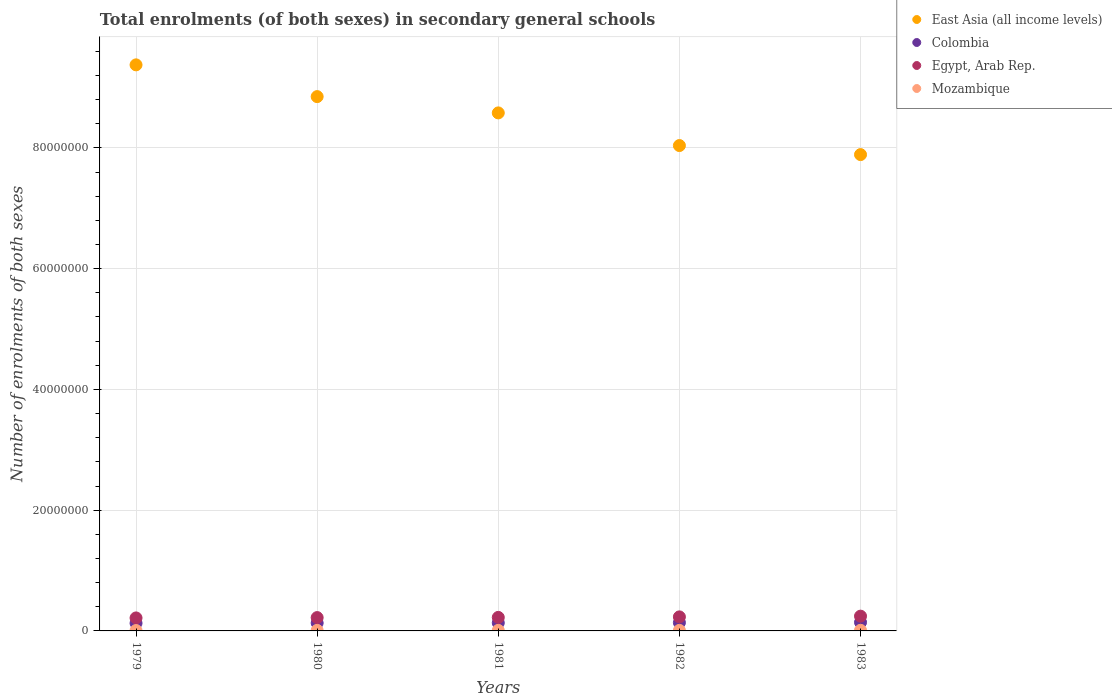How many different coloured dotlines are there?
Your answer should be compact. 4. Is the number of dotlines equal to the number of legend labels?
Provide a succinct answer. Yes. What is the number of enrolments in secondary schools in Colombia in 1982?
Make the answer very short. 1.37e+06. Across all years, what is the maximum number of enrolments in secondary schools in East Asia (all income levels)?
Your answer should be very brief. 9.38e+07. Across all years, what is the minimum number of enrolments in secondary schools in East Asia (all income levels)?
Ensure brevity in your answer.  7.89e+07. In which year was the number of enrolments in secondary schools in Colombia minimum?
Offer a very short reply. 1979. What is the total number of enrolments in secondary schools in Mozambique in the graph?
Give a very brief answer. 4.46e+05. What is the difference between the number of enrolments in secondary schools in East Asia (all income levels) in 1979 and that in 1981?
Provide a succinct answer. 7.96e+06. What is the difference between the number of enrolments in secondary schools in Mozambique in 1981 and the number of enrolments in secondary schools in Egypt, Arab Rep. in 1982?
Ensure brevity in your answer.  -2.24e+06. What is the average number of enrolments in secondary schools in Mozambique per year?
Offer a terse response. 8.91e+04. In the year 1983, what is the difference between the number of enrolments in secondary schools in Colombia and number of enrolments in secondary schools in East Asia (all income levels)?
Offer a terse response. -7.75e+07. In how many years, is the number of enrolments in secondary schools in Colombia greater than 20000000?
Provide a short and direct response. 0. What is the ratio of the number of enrolments in secondary schools in Egypt, Arab Rep. in 1979 to that in 1981?
Your answer should be compact. 0.96. Is the number of enrolments in secondary schools in East Asia (all income levels) in 1980 less than that in 1983?
Make the answer very short. No. Is the difference between the number of enrolments in secondary schools in Colombia in 1979 and 1980 greater than the difference between the number of enrolments in secondary schools in East Asia (all income levels) in 1979 and 1980?
Provide a short and direct response. No. What is the difference between the highest and the second highest number of enrolments in secondary schools in East Asia (all income levels)?
Offer a very short reply. 5.26e+06. What is the difference between the highest and the lowest number of enrolments in secondary schools in Egypt, Arab Rep.?
Keep it short and to the point. 2.93e+05. Is it the case that in every year, the sum of the number of enrolments in secondary schools in East Asia (all income levels) and number of enrolments in secondary schools in Mozambique  is greater than the sum of number of enrolments in secondary schools in Colombia and number of enrolments in secondary schools in Egypt, Arab Rep.?
Provide a succinct answer. No. Is the number of enrolments in secondary schools in Mozambique strictly greater than the number of enrolments in secondary schools in Egypt, Arab Rep. over the years?
Your answer should be compact. No. What is the title of the graph?
Your answer should be very brief. Total enrolments (of both sexes) in secondary general schools. What is the label or title of the Y-axis?
Your answer should be very brief. Number of enrolments of both sexes. What is the Number of enrolments of both sexes of East Asia (all income levels) in 1979?
Give a very brief answer. 9.38e+07. What is the Number of enrolments of both sexes in Colombia in 1979?
Your response must be concise. 1.28e+06. What is the Number of enrolments of both sexes of Egypt, Arab Rep. in 1979?
Provide a succinct answer. 2.15e+06. What is the Number of enrolments of both sexes of Mozambique in 1979?
Offer a very short reply. 6.74e+04. What is the Number of enrolments of both sexes in East Asia (all income levels) in 1980?
Ensure brevity in your answer.  8.85e+07. What is the Number of enrolments of both sexes in Colombia in 1980?
Your response must be concise. 1.31e+06. What is the Number of enrolments of both sexes in Egypt, Arab Rep. in 1980?
Provide a succinct answer. 2.21e+06. What is the Number of enrolments of both sexes in Mozambique in 1980?
Your response must be concise. 9.28e+04. What is the Number of enrolments of both sexes of East Asia (all income levels) in 1981?
Provide a succinct answer. 8.58e+07. What is the Number of enrolments of both sexes in Colombia in 1981?
Your answer should be very brief. 1.34e+06. What is the Number of enrolments of both sexes in Egypt, Arab Rep. in 1981?
Keep it short and to the point. 2.24e+06. What is the Number of enrolments of both sexes of Mozambique in 1981?
Make the answer very short. 9.00e+04. What is the Number of enrolments of both sexes in East Asia (all income levels) in 1982?
Ensure brevity in your answer.  8.04e+07. What is the Number of enrolments of both sexes of Colombia in 1982?
Ensure brevity in your answer.  1.37e+06. What is the Number of enrolments of both sexes in Egypt, Arab Rep. in 1982?
Ensure brevity in your answer.  2.33e+06. What is the Number of enrolments of both sexes of Mozambique in 1982?
Provide a short and direct response. 8.98e+04. What is the Number of enrolments of both sexes of East Asia (all income levels) in 1983?
Your response must be concise. 7.89e+07. What is the Number of enrolments of both sexes of Colombia in 1983?
Provide a short and direct response. 1.42e+06. What is the Number of enrolments of both sexes of Egypt, Arab Rep. in 1983?
Give a very brief answer. 2.45e+06. What is the Number of enrolments of both sexes in Mozambique in 1983?
Keep it short and to the point. 1.05e+05. Across all years, what is the maximum Number of enrolments of both sexes of East Asia (all income levels)?
Give a very brief answer. 9.38e+07. Across all years, what is the maximum Number of enrolments of both sexes in Colombia?
Make the answer very short. 1.42e+06. Across all years, what is the maximum Number of enrolments of both sexes of Egypt, Arab Rep.?
Keep it short and to the point. 2.45e+06. Across all years, what is the maximum Number of enrolments of both sexes in Mozambique?
Offer a very short reply. 1.05e+05. Across all years, what is the minimum Number of enrolments of both sexes in East Asia (all income levels)?
Give a very brief answer. 7.89e+07. Across all years, what is the minimum Number of enrolments of both sexes in Colombia?
Ensure brevity in your answer.  1.28e+06. Across all years, what is the minimum Number of enrolments of both sexes in Egypt, Arab Rep.?
Offer a terse response. 2.15e+06. Across all years, what is the minimum Number of enrolments of both sexes in Mozambique?
Your answer should be compact. 6.74e+04. What is the total Number of enrolments of both sexes of East Asia (all income levels) in the graph?
Keep it short and to the point. 4.27e+08. What is the total Number of enrolments of both sexes in Colombia in the graph?
Your answer should be compact. 6.73e+06. What is the total Number of enrolments of both sexes in Egypt, Arab Rep. in the graph?
Ensure brevity in your answer.  1.14e+07. What is the total Number of enrolments of both sexes of Mozambique in the graph?
Offer a very short reply. 4.46e+05. What is the difference between the Number of enrolments of both sexes of East Asia (all income levels) in 1979 and that in 1980?
Give a very brief answer. 5.26e+06. What is the difference between the Number of enrolments of both sexes of Colombia in 1979 and that in 1980?
Your answer should be very brief. -3.55e+04. What is the difference between the Number of enrolments of both sexes in Egypt, Arab Rep. in 1979 and that in 1980?
Your response must be concise. -5.67e+04. What is the difference between the Number of enrolments of both sexes of Mozambique in 1979 and that in 1980?
Your response must be concise. -2.54e+04. What is the difference between the Number of enrolments of both sexes in East Asia (all income levels) in 1979 and that in 1981?
Give a very brief answer. 7.96e+06. What is the difference between the Number of enrolments of both sexes in Colombia in 1979 and that in 1981?
Make the answer very short. -6.07e+04. What is the difference between the Number of enrolments of both sexes in Egypt, Arab Rep. in 1979 and that in 1981?
Ensure brevity in your answer.  -8.68e+04. What is the difference between the Number of enrolments of both sexes of Mozambique in 1979 and that in 1981?
Make the answer very short. -2.26e+04. What is the difference between the Number of enrolments of both sexes in East Asia (all income levels) in 1979 and that in 1982?
Your response must be concise. 1.34e+07. What is the difference between the Number of enrolments of both sexes of Colombia in 1979 and that in 1982?
Ensure brevity in your answer.  -9.71e+04. What is the difference between the Number of enrolments of both sexes in Egypt, Arab Rep. in 1979 and that in 1982?
Provide a short and direct response. -1.74e+05. What is the difference between the Number of enrolments of both sexes in Mozambique in 1979 and that in 1982?
Make the answer very short. -2.24e+04. What is the difference between the Number of enrolments of both sexes of East Asia (all income levels) in 1979 and that in 1983?
Provide a short and direct response. 1.49e+07. What is the difference between the Number of enrolments of both sexes in Colombia in 1979 and that in 1983?
Ensure brevity in your answer.  -1.47e+05. What is the difference between the Number of enrolments of both sexes in Egypt, Arab Rep. in 1979 and that in 1983?
Keep it short and to the point. -2.93e+05. What is the difference between the Number of enrolments of both sexes of Mozambique in 1979 and that in 1983?
Provide a short and direct response. -3.80e+04. What is the difference between the Number of enrolments of both sexes in East Asia (all income levels) in 1980 and that in 1981?
Ensure brevity in your answer.  2.70e+06. What is the difference between the Number of enrolments of both sexes in Colombia in 1980 and that in 1981?
Make the answer very short. -2.52e+04. What is the difference between the Number of enrolments of both sexes of Egypt, Arab Rep. in 1980 and that in 1981?
Provide a succinct answer. -3.02e+04. What is the difference between the Number of enrolments of both sexes in Mozambique in 1980 and that in 1981?
Offer a terse response. 2774. What is the difference between the Number of enrolments of both sexes in East Asia (all income levels) in 1980 and that in 1982?
Offer a very short reply. 8.11e+06. What is the difference between the Number of enrolments of both sexes in Colombia in 1980 and that in 1982?
Your response must be concise. -6.17e+04. What is the difference between the Number of enrolments of both sexes of Egypt, Arab Rep. in 1980 and that in 1982?
Your answer should be compact. -1.18e+05. What is the difference between the Number of enrolments of both sexes in Mozambique in 1980 and that in 1982?
Provide a succinct answer. 2980. What is the difference between the Number of enrolments of both sexes of East Asia (all income levels) in 1980 and that in 1983?
Your answer should be very brief. 9.61e+06. What is the difference between the Number of enrolments of both sexes of Colombia in 1980 and that in 1983?
Make the answer very short. -1.11e+05. What is the difference between the Number of enrolments of both sexes of Egypt, Arab Rep. in 1980 and that in 1983?
Offer a terse response. -2.37e+05. What is the difference between the Number of enrolments of both sexes of Mozambique in 1980 and that in 1983?
Give a very brief answer. -1.26e+04. What is the difference between the Number of enrolments of both sexes in East Asia (all income levels) in 1981 and that in 1982?
Provide a short and direct response. 5.41e+06. What is the difference between the Number of enrolments of both sexes in Colombia in 1981 and that in 1982?
Give a very brief answer. -3.65e+04. What is the difference between the Number of enrolments of both sexes in Egypt, Arab Rep. in 1981 and that in 1982?
Ensure brevity in your answer.  -8.73e+04. What is the difference between the Number of enrolments of both sexes of Mozambique in 1981 and that in 1982?
Your response must be concise. 206. What is the difference between the Number of enrolments of both sexes in East Asia (all income levels) in 1981 and that in 1983?
Offer a very short reply. 6.91e+06. What is the difference between the Number of enrolments of both sexes in Colombia in 1981 and that in 1983?
Provide a succinct answer. -8.62e+04. What is the difference between the Number of enrolments of both sexes of Egypt, Arab Rep. in 1981 and that in 1983?
Keep it short and to the point. -2.07e+05. What is the difference between the Number of enrolments of both sexes in Mozambique in 1981 and that in 1983?
Your answer should be very brief. -1.54e+04. What is the difference between the Number of enrolments of both sexes of East Asia (all income levels) in 1982 and that in 1983?
Give a very brief answer. 1.50e+06. What is the difference between the Number of enrolments of both sexes in Colombia in 1982 and that in 1983?
Provide a short and direct response. -4.97e+04. What is the difference between the Number of enrolments of both sexes in Egypt, Arab Rep. in 1982 and that in 1983?
Your answer should be very brief. -1.19e+05. What is the difference between the Number of enrolments of both sexes of Mozambique in 1982 and that in 1983?
Offer a terse response. -1.56e+04. What is the difference between the Number of enrolments of both sexes of East Asia (all income levels) in 1979 and the Number of enrolments of both sexes of Colombia in 1980?
Keep it short and to the point. 9.24e+07. What is the difference between the Number of enrolments of both sexes of East Asia (all income levels) in 1979 and the Number of enrolments of both sexes of Egypt, Arab Rep. in 1980?
Your answer should be very brief. 9.15e+07. What is the difference between the Number of enrolments of both sexes of East Asia (all income levels) in 1979 and the Number of enrolments of both sexes of Mozambique in 1980?
Your response must be concise. 9.37e+07. What is the difference between the Number of enrolments of both sexes of Colombia in 1979 and the Number of enrolments of both sexes of Egypt, Arab Rep. in 1980?
Provide a short and direct response. -9.31e+05. What is the difference between the Number of enrolments of both sexes in Colombia in 1979 and the Number of enrolments of both sexes in Mozambique in 1980?
Your answer should be compact. 1.18e+06. What is the difference between the Number of enrolments of both sexes in Egypt, Arab Rep. in 1979 and the Number of enrolments of both sexes in Mozambique in 1980?
Provide a short and direct response. 2.06e+06. What is the difference between the Number of enrolments of both sexes of East Asia (all income levels) in 1979 and the Number of enrolments of both sexes of Colombia in 1981?
Give a very brief answer. 9.24e+07. What is the difference between the Number of enrolments of both sexes in East Asia (all income levels) in 1979 and the Number of enrolments of both sexes in Egypt, Arab Rep. in 1981?
Keep it short and to the point. 9.15e+07. What is the difference between the Number of enrolments of both sexes in East Asia (all income levels) in 1979 and the Number of enrolments of both sexes in Mozambique in 1981?
Your answer should be compact. 9.37e+07. What is the difference between the Number of enrolments of both sexes in Colombia in 1979 and the Number of enrolments of both sexes in Egypt, Arab Rep. in 1981?
Ensure brevity in your answer.  -9.61e+05. What is the difference between the Number of enrolments of both sexes of Colombia in 1979 and the Number of enrolments of both sexes of Mozambique in 1981?
Your answer should be very brief. 1.19e+06. What is the difference between the Number of enrolments of both sexes in Egypt, Arab Rep. in 1979 and the Number of enrolments of both sexes in Mozambique in 1981?
Keep it short and to the point. 2.06e+06. What is the difference between the Number of enrolments of both sexes in East Asia (all income levels) in 1979 and the Number of enrolments of both sexes in Colombia in 1982?
Offer a terse response. 9.24e+07. What is the difference between the Number of enrolments of both sexes in East Asia (all income levels) in 1979 and the Number of enrolments of both sexes in Egypt, Arab Rep. in 1982?
Provide a short and direct response. 9.14e+07. What is the difference between the Number of enrolments of both sexes in East Asia (all income levels) in 1979 and the Number of enrolments of both sexes in Mozambique in 1982?
Your answer should be very brief. 9.37e+07. What is the difference between the Number of enrolments of both sexes in Colombia in 1979 and the Number of enrolments of both sexes in Egypt, Arab Rep. in 1982?
Keep it short and to the point. -1.05e+06. What is the difference between the Number of enrolments of both sexes in Colombia in 1979 and the Number of enrolments of both sexes in Mozambique in 1982?
Provide a succinct answer. 1.19e+06. What is the difference between the Number of enrolments of both sexes of Egypt, Arab Rep. in 1979 and the Number of enrolments of both sexes of Mozambique in 1982?
Provide a succinct answer. 2.06e+06. What is the difference between the Number of enrolments of both sexes in East Asia (all income levels) in 1979 and the Number of enrolments of both sexes in Colombia in 1983?
Give a very brief answer. 9.23e+07. What is the difference between the Number of enrolments of both sexes of East Asia (all income levels) in 1979 and the Number of enrolments of both sexes of Egypt, Arab Rep. in 1983?
Your answer should be compact. 9.13e+07. What is the difference between the Number of enrolments of both sexes of East Asia (all income levels) in 1979 and the Number of enrolments of both sexes of Mozambique in 1983?
Your answer should be compact. 9.36e+07. What is the difference between the Number of enrolments of both sexes in Colombia in 1979 and the Number of enrolments of both sexes in Egypt, Arab Rep. in 1983?
Keep it short and to the point. -1.17e+06. What is the difference between the Number of enrolments of both sexes of Colombia in 1979 and the Number of enrolments of both sexes of Mozambique in 1983?
Keep it short and to the point. 1.17e+06. What is the difference between the Number of enrolments of both sexes in Egypt, Arab Rep. in 1979 and the Number of enrolments of both sexes in Mozambique in 1983?
Keep it short and to the point. 2.05e+06. What is the difference between the Number of enrolments of both sexes in East Asia (all income levels) in 1980 and the Number of enrolments of both sexes in Colombia in 1981?
Your response must be concise. 8.72e+07. What is the difference between the Number of enrolments of both sexes in East Asia (all income levels) in 1980 and the Number of enrolments of both sexes in Egypt, Arab Rep. in 1981?
Offer a very short reply. 8.63e+07. What is the difference between the Number of enrolments of both sexes in East Asia (all income levels) in 1980 and the Number of enrolments of both sexes in Mozambique in 1981?
Make the answer very short. 8.84e+07. What is the difference between the Number of enrolments of both sexes in Colombia in 1980 and the Number of enrolments of both sexes in Egypt, Arab Rep. in 1981?
Your response must be concise. -9.26e+05. What is the difference between the Number of enrolments of both sexes in Colombia in 1980 and the Number of enrolments of both sexes in Mozambique in 1981?
Offer a very short reply. 1.22e+06. What is the difference between the Number of enrolments of both sexes in Egypt, Arab Rep. in 1980 and the Number of enrolments of both sexes in Mozambique in 1981?
Your answer should be compact. 2.12e+06. What is the difference between the Number of enrolments of both sexes of East Asia (all income levels) in 1980 and the Number of enrolments of both sexes of Colombia in 1982?
Ensure brevity in your answer.  8.71e+07. What is the difference between the Number of enrolments of both sexes of East Asia (all income levels) in 1980 and the Number of enrolments of both sexes of Egypt, Arab Rep. in 1982?
Keep it short and to the point. 8.62e+07. What is the difference between the Number of enrolments of both sexes in East Asia (all income levels) in 1980 and the Number of enrolments of both sexes in Mozambique in 1982?
Keep it short and to the point. 8.84e+07. What is the difference between the Number of enrolments of both sexes of Colombia in 1980 and the Number of enrolments of both sexes of Egypt, Arab Rep. in 1982?
Provide a succinct answer. -1.01e+06. What is the difference between the Number of enrolments of both sexes of Colombia in 1980 and the Number of enrolments of both sexes of Mozambique in 1982?
Your response must be concise. 1.22e+06. What is the difference between the Number of enrolments of both sexes in Egypt, Arab Rep. in 1980 and the Number of enrolments of both sexes in Mozambique in 1982?
Provide a succinct answer. 2.12e+06. What is the difference between the Number of enrolments of both sexes in East Asia (all income levels) in 1980 and the Number of enrolments of both sexes in Colombia in 1983?
Provide a short and direct response. 8.71e+07. What is the difference between the Number of enrolments of both sexes of East Asia (all income levels) in 1980 and the Number of enrolments of both sexes of Egypt, Arab Rep. in 1983?
Provide a succinct answer. 8.60e+07. What is the difference between the Number of enrolments of both sexes in East Asia (all income levels) in 1980 and the Number of enrolments of both sexes in Mozambique in 1983?
Offer a very short reply. 8.84e+07. What is the difference between the Number of enrolments of both sexes in Colombia in 1980 and the Number of enrolments of both sexes in Egypt, Arab Rep. in 1983?
Make the answer very short. -1.13e+06. What is the difference between the Number of enrolments of both sexes of Colombia in 1980 and the Number of enrolments of both sexes of Mozambique in 1983?
Provide a succinct answer. 1.21e+06. What is the difference between the Number of enrolments of both sexes in Egypt, Arab Rep. in 1980 and the Number of enrolments of both sexes in Mozambique in 1983?
Provide a short and direct response. 2.10e+06. What is the difference between the Number of enrolments of both sexes of East Asia (all income levels) in 1981 and the Number of enrolments of both sexes of Colombia in 1982?
Provide a short and direct response. 8.44e+07. What is the difference between the Number of enrolments of both sexes in East Asia (all income levels) in 1981 and the Number of enrolments of both sexes in Egypt, Arab Rep. in 1982?
Offer a very short reply. 8.35e+07. What is the difference between the Number of enrolments of both sexes of East Asia (all income levels) in 1981 and the Number of enrolments of both sexes of Mozambique in 1982?
Make the answer very short. 8.57e+07. What is the difference between the Number of enrolments of both sexes of Colombia in 1981 and the Number of enrolments of both sexes of Egypt, Arab Rep. in 1982?
Provide a succinct answer. -9.88e+05. What is the difference between the Number of enrolments of both sexes of Colombia in 1981 and the Number of enrolments of both sexes of Mozambique in 1982?
Give a very brief answer. 1.25e+06. What is the difference between the Number of enrolments of both sexes in Egypt, Arab Rep. in 1981 and the Number of enrolments of both sexes in Mozambique in 1982?
Your answer should be very brief. 2.15e+06. What is the difference between the Number of enrolments of both sexes of East Asia (all income levels) in 1981 and the Number of enrolments of both sexes of Colombia in 1983?
Provide a succinct answer. 8.44e+07. What is the difference between the Number of enrolments of both sexes of East Asia (all income levels) in 1981 and the Number of enrolments of both sexes of Egypt, Arab Rep. in 1983?
Give a very brief answer. 8.33e+07. What is the difference between the Number of enrolments of both sexes in East Asia (all income levels) in 1981 and the Number of enrolments of both sexes in Mozambique in 1983?
Offer a terse response. 8.57e+07. What is the difference between the Number of enrolments of both sexes of Colombia in 1981 and the Number of enrolments of both sexes of Egypt, Arab Rep. in 1983?
Provide a short and direct response. -1.11e+06. What is the difference between the Number of enrolments of both sexes of Colombia in 1981 and the Number of enrolments of both sexes of Mozambique in 1983?
Ensure brevity in your answer.  1.23e+06. What is the difference between the Number of enrolments of both sexes in Egypt, Arab Rep. in 1981 and the Number of enrolments of both sexes in Mozambique in 1983?
Keep it short and to the point. 2.13e+06. What is the difference between the Number of enrolments of both sexes of East Asia (all income levels) in 1982 and the Number of enrolments of both sexes of Colombia in 1983?
Your response must be concise. 7.90e+07. What is the difference between the Number of enrolments of both sexes of East Asia (all income levels) in 1982 and the Number of enrolments of both sexes of Egypt, Arab Rep. in 1983?
Provide a succinct answer. 7.79e+07. What is the difference between the Number of enrolments of both sexes of East Asia (all income levels) in 1982 and the Number of enrolments of both sexes of Mozambique in 1983?
Provide a short and direct response. 8.03e+07. What is the difference between the Number of enrolments of both sexes of Colombia in 1982 and the Number of enrolments of both sexes of Egypt, Arab Rep. in 1983?
Your response must be concise. -1.07e+06. What is the difference between the Number of enrolments of both sexes in Colombia in 1982 and the Number of enrolments of both sexes in Mozambique in 1983?
Provide a succinct answer. 1.27e+06. What is the difference between the Number of enrolments of both sexes of Egypt, Arab Rep. in 1982 and the Number of enrolments of both sexes of Mozambique in 1983?
Your answer should be compact. 2.22e+06. What is the average Number of enrolments of both sexes of East Asia (all income levels) per year?
Your answer should be very brief. 8.55e+07. What is the average Number of enrolments of both sexes in Colombia per year?
Keep it short and to the point. 1.35e+06. What is the average Number of enrolments of both sexes in Egypt, Arab Rep. per year?
Ensure brevity in your answer.  2.27e+06. What is the average Number of enrolments of both sexes of Mozambique per year?
Offer a very short reply. 8.91e+04. In the year 1979, what is the difference between the Number of enrolments of both sexes of East Asia (all income levels) and Number of enrolments of both sexes of Colombia?
Provide a short and direct response. 9.25e+07. In the year 1979, what is the difference between the Number of enrolments of both sexes in East Asia (all income levels) and Number of enrolments of both sexes in Egypt, Arab Rep.?
Keep it short and to the point. 9.16e+07. In the year 1979, what is the difference between the Number of enrolments of both sexes of East Asia (all income levels) and Number of enrolments of both sexes of Mozambique?
Offer a terse response. 9.37e+07. In the year 1979, what is the difference between the Number of enrolments of both sexes in Colombia and Number of enrolments of both sexes in Egypt, Arab Rep.?
Give a very brief answer. -8.74e+05. In the year 1979, what is the difference between the Number of enrolments of both sexes in Colombia and Number of enrolments of both sexes in Mozambique?
Make the answer very short. 1.21e+06. In the year 1979, what is the difference between the Number of enrolments of both sexes in Egypt, Arab Rep. and Number of enrolments of both sexes in Mozambique?
Offer a very short reply. 2.08e+06. In the year 1980, what is the difference between the Number of enrolments of both sexes of East Asia (all income levels) and Number of enrolments of both sexes of Colombia?
Make the answer very short. 8.72e+07. In the year 1980, what is the difference between the Number of enrolments of both sexes in East Asia (all income levels) and Number of enrolments of both sexes in Egypt, Arab Rep.?
Keep it short and to the point. 8.63e+07. In the year 1980, what is the difference between the Number of enrolments of both sexes of East Asia (all income levels) and Number of enrolments of both sexes of Mozambique?
Your answer should be compact. 8.84e+07. In the year 1980, what is the difference between the Number of enrolments of both sexes in Colombia and Number of enrolments of both sexes in Egypt, Arab Rep.?
Provide a short and direct response. -8.96e+05. In the year 1980, what is the difference between the Number of enrolments of both sexes of Colombia and Number of enrolments of both sexes of Mozambique?
Provide a short and direct response. 1.22e+06. In the year 1980, what is the difference between the Number of enrolments of both sexes in Egypt, Arab Rep. and Number of enrolments of both sexes in Mozambique?
Provide a succinct answer. 2.12e+06. In the year 1981, what is the difference between the Number of enrolments of both sexes of East Asia (all income levels) and Number of enrolments of both sexes of Colombia?
Your answer should be very brief. 8.45e+07. In the year 1981, what is the difference between the Number of enrolments of both sexes of East Asia (all income levels) and Number of enrolments of both sexes of Egypt, Arab Rep.?
Ensure brevity in your answer.  8.36e+07. In the year 1981, what is the difference between the Number of enrolments of both sexes of East Asia (all income levels) and Number of enrolments of both sexes of Mozambique?
Keep it short and to the point. 8.57e+07. In the year 1981, what is the difference between the Number of enrolments of both sexes in Colombia and Number of enrolments of both sexes in Egypt, Arab Rep.?
Your answer should be compact. -9.01e+05. In the year 1981, what is the difference between the Number of enrolments of both sexes in Colombia and Number of enrolments of both sexes in Mozambique?
Ensure brevity in your answer.  1.25e+06. In the year 1981, what is the difference between the Number of enrolments of both sexes in Egypt, Arab Rep. and Number of enrolments of both sexes in Mozambique?
Your answer should be very brief. 2.15e+06. In the year 1982, what is the difference between the Number of enrolments of both sexes in East Asia (all income levels) and Number of enrolments of both sexes in Colombia?
Make the answer very short. 7.90e+07. In the year 1982, what is the difference between the Number of enrolments of both sexes of East Asia (all income levels) and Number of enrolments of both sexes of Egypt, Arab Rep.?
Your answer should be compact. 7.81e+07. In the year 1982, what is the difference between the Number of enrolments of both sexes in East Asia (all income levels) and Number of enrolments of both sexes in Mozambique?
Offer a very short reply. 8.03e+07. In the year 1982, what is the difference between the Number of enrolments of both sexes of Colombia and Number of enrolments of both sexes of Egypt, Arab Rep.?
Keep it short and to the point. -9.52e+05. In the year 1982, what is the difference between the Number of enrolments of both sexes in Colombia and Number of enrolments of both sexes in Mozambique?
Provide a succinct answer. 1.28e+06. In the year 1982, what is the difference between the Number of enrolments of both sexes in Egypt, Arab Rep. and Number of enrolments of both sexes in Mozambique?
Keep it short and to the point. 2.24e+06. In the year 1983, what is the difference between the Number of enrolments of both sexes in East Asia (all income levels) and Number of enrolments of both sexes in Colombia?
Ensure brevity in your answer.  7.75e+07. In the year 1983, what is the difference between the Number of enrolments of both sexes in East Asia (all income levels) and Number of enrolments of both sexes in Egypt, Arab Rep.?
Provide a short and direct response. 7.64e+07. In the year 1983, what is the difference between the Number of enrolments of both sexes of East Asia (all income levels) and Number of enrolments of both sexes of Mozambique?
Offer a terse response. 7.88e+07. In the year 1983, what is the difference between the Number of enrolments of both sexes in Colombia and Number of enrolments of both sexes in Egypt, Arab Rep.?
Offer a terse response. -1.02e+06. In the year 1983, what is the difference between the Number of enrolments of both sexes in Colombia and Number of enrolments of both sexes in Mozambique?
Make the answer very short. 1.32e+06. In the year 1983, what is the difference between the Number of enrolments of both sexes of Egypt, Arab Rep. and Number of enrolments of both sexes of Mozambique?
Keep it short and to the point. 2.34e+06. What is the ratio of the Number of enrolments of both sexes of East Asia (all income levels) in 1979 to that in 1980?
Provide a succinct answer. 1.06. What is the ratio of the Number of enrolments of both sexes in Egypt, Arab Rep. in 1979 to that in 1980?
Keep it short and to the point. 0.97. What is the ratio of the Number of enrolments of both sexes in Mozambique in 1979 to that in 1980?
Your answer should be compact. 0.73. What is the ratio of the Number of enrolments of both sexes of East Asia (all income levels) in 1979 to that in 1981?
Provide a succinct answer. 1.09. What is the ratio of the Number of enrolments of both sexes in Colombia in 1979 to that in 1981?
Offer a very short reply. 0.95. What is the ratio of the Number of enrolments of both sexes in Egypt, Arab Rep. in 1979 to that in 1981?
Provide a short and direct response. 0.96. What is the ratio of the Number of enrolments of both sexes of Mozambique in 1979 to that in 1981?
Your answer should be compact. 0.75. What is the ratio of the Number of enrolments of both sexes of East Asia (all income levels) in 1979 to that in 1982?
Offer a very short reply. 1.17. What is the ratio of the Number of enrolments of both sexes in Colombia in 1979 to that in 1982?
Provide a succinct answer. 0.93. What is the ratio of the Number of enrolments of both sexes of Egypt, Arab Rep. in 1979 to that in 1982?
Provide a short and direct response. 0.93. What is the ratio of the Number of enrolments of both sexes in Mozambique in 1979 to that in 1982?
Your response must be concise. 0.75. What is the ratio of the Number of enrolments of both sexes in East Asia (all income levels) in 1979 to that in 1983?
Make the answer very short. 1.19. What is the ratio of the Number of enrolments of both sexes of Colombia in 1979 to that in 1983?
Your answer should be compact. 0.9. What is the ratio of the Number of enrolments of both sexes in Mozambique in 1979 to that in 1983?
Provide a short and direct response. 0.64. What is the ratio of the Number of enrolments of both sexes of East Asia (all income levels) in 1980 to that in 1981?
Your answer should be very brief. 1.03. What is the ratio of the Number of enrolments of both sexes of Colombia in 1980 to that in 1981?
Your answer should be very brief. 0.98. What is the ratio of the Number of enrolments of both sexes of Egypt, Arab Rep. in 1980 to that in 1981?
Your answer should be compact. 0.99. What is the ratio of the Number of enrolments of both sexes of Mozambique in 1980 to that in 1981?
Provide a succinct answer. 1.03. What is the ratio of the Number of enrolments of both sexes in East Asia (all income levels) in 1980 to that in 1982?
Ensure brevity in your answer.  1.1. What is the ratio of the Number of enrolments of both sexes in Colombia in 1980 to that in 1982?
Offer a terse response. 0.96. What is the ratio of the Number of enrolments of both sexes in Egypt, Arab Rep. in 1980 to that in 1982?
Give a very brief answer. 0.95. What is the ratio of the Number of enrolments of both sexes in Mozambique in 1980 to that in 1982?
Your answer should be very brief. 1.03. What is the ratio of the Number of enrolments of both sexes of East Asia (all income levels) in 1980 to that in 1983?
Your answer should be very brief. 1.12. What is the ratio of the Number of enrolments of both sexes in Colombia in 1980 to that in 1983?
Offer a very short reply. 0.92. What is the ratio of the Number of enrolments of both sexes in Egypt, Arab Rep. in 1980 to that in 1983?
Make the answer very short. 0.9. What is the ratio of the Number of enrolments of both sexes in Mozambique in 1980 to that in 1983?
Ensure brevity in your answer.  0.88. What is the ratio of the Number of enrolments of both sexes in East Asia (all income levels) in 1981 to that in 1982?
Make the answer very short. 1.07. What is the ratio of the Number of enrolments of both sexes in Colombia in 1981 to that in 1982?
Provide a succinct answer. 0.97. What is the ratio of the Number of enrolments of both sexes in Egypt, Arab Rep. in 1981 to that in 1982?
Offer a very short reply. 0.96. What is the ratio of the Number of enrolments of both sexes of Mozambique in 1981 to that in 1982?
Offer a very short reply. 1. What is the ratio of the Number of enrolments of both sexes in East Asia (all income levels) in 1981 to that in 1983?
Your answer should be very brief. 1.09. What is the ratio of the Number of enrolments of both sexes of Colombia in 1981 to that in 1983?
Your answer should be very brief. 0.94. What is the ratio of the Number of enrolments of both sexes in Egypt, Arab Rep. in 1981 to that in 1983?
Ensure brevity in your answer.  0.92. What is the ratio of the Number of enrolments of both sexes in Mozambique in 1981 to that in 1983?
Your answer should be very brief. 0.85. What is the ratio of the Number of enrolments of both sexes in Colombia in 1982 to that in 1983?
Give a very brief answer. 0.97. What is the ratio of the Number of enrolments of both sexes of Egypt, Arab Rep. in 1982 to that in 1983?
Provide a succinct answer. 0.95. What is the ratio of the Number of enrolments of both sexes in Mozambique in 1982 to that in 1983?
Keep it short and to the point. 0.85. What is the difference between the highest and the second highest Number of enrolments of both sexes in East Asia (all income levels)?
Give a very brief answer. 5.26e+06. What is the difference between the highest and the second highest Number of enrolments of both sexes of Colombia?
Make the answer very short. 4.97e+04. What is the difference between the highest and the second highest Number of enrolments of both sexes in Egypt, Arab Rep.?
Ensure brevity in your answer.  1.19e+05. What is the difference between the highest and the second highest Number of enrolments of both sexes of Mozambique?
Your answer should be compact. 1.26e+04. What is the difference between the highest and the lowest Number of enrolments of both sexes in East Asia (all income levels)?
Offer a terse response. 1.49e+07. What is the difference between the highest and the lowest Number of enrolments of both sexes of Colombia?
Make the answer very short. 1.47e+05. What is the difference between the highest and the lowest Number of enrolments of both sexes in Egypt, Arab Rep.?
Provide a short and direct response. 2.93e+05. What is the difference between the highest and the lowest Number of enrolments of both sexes in Mozambique?
Provide a succinct answer. 3.80e+04. 